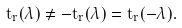Convert formula to latex. <formula><loc_0><loc_0><loc_500><loc_500>t _ { r } ( \lambda ) \ne - t _ { r } ( \lambda ) = t _ { r } ( - \lambda ) .</formula> 